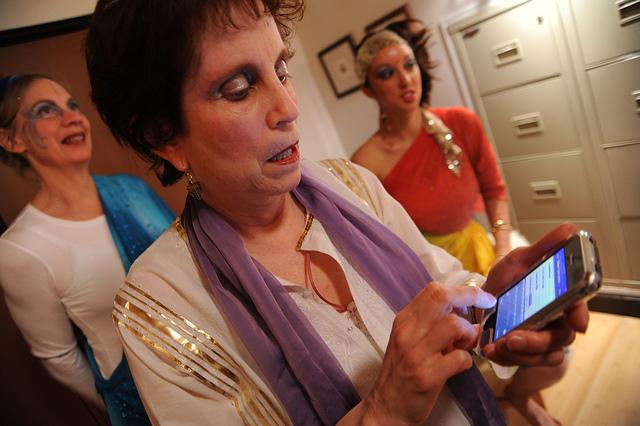Where do the women likely work?
Be succinct. Theater. Is this a smartphone?
Write a very short answer. Yes. Is this photo in color?
Write a very short answer. Yes. What type of phone does the lady have?
Give a very brief answer. Smartphone. Is this woman looking at the camera?
Concise answer only. No. What type of shirt or top is the woman in this image wearing?
Answer briefly. Blouse. How many women do you see?
Give a very brief answer. 3. Does the lady have long hair?
Short answer required. No. Is her hand facing up?
Quick response, please. No. What color are the devices the people are typing on?
Write a very short answer. Silver. Are they dressed for Halloween?
Concise answer only. Yes. Are they all wearing heavy makeup?
Quick response, please. Yes. 